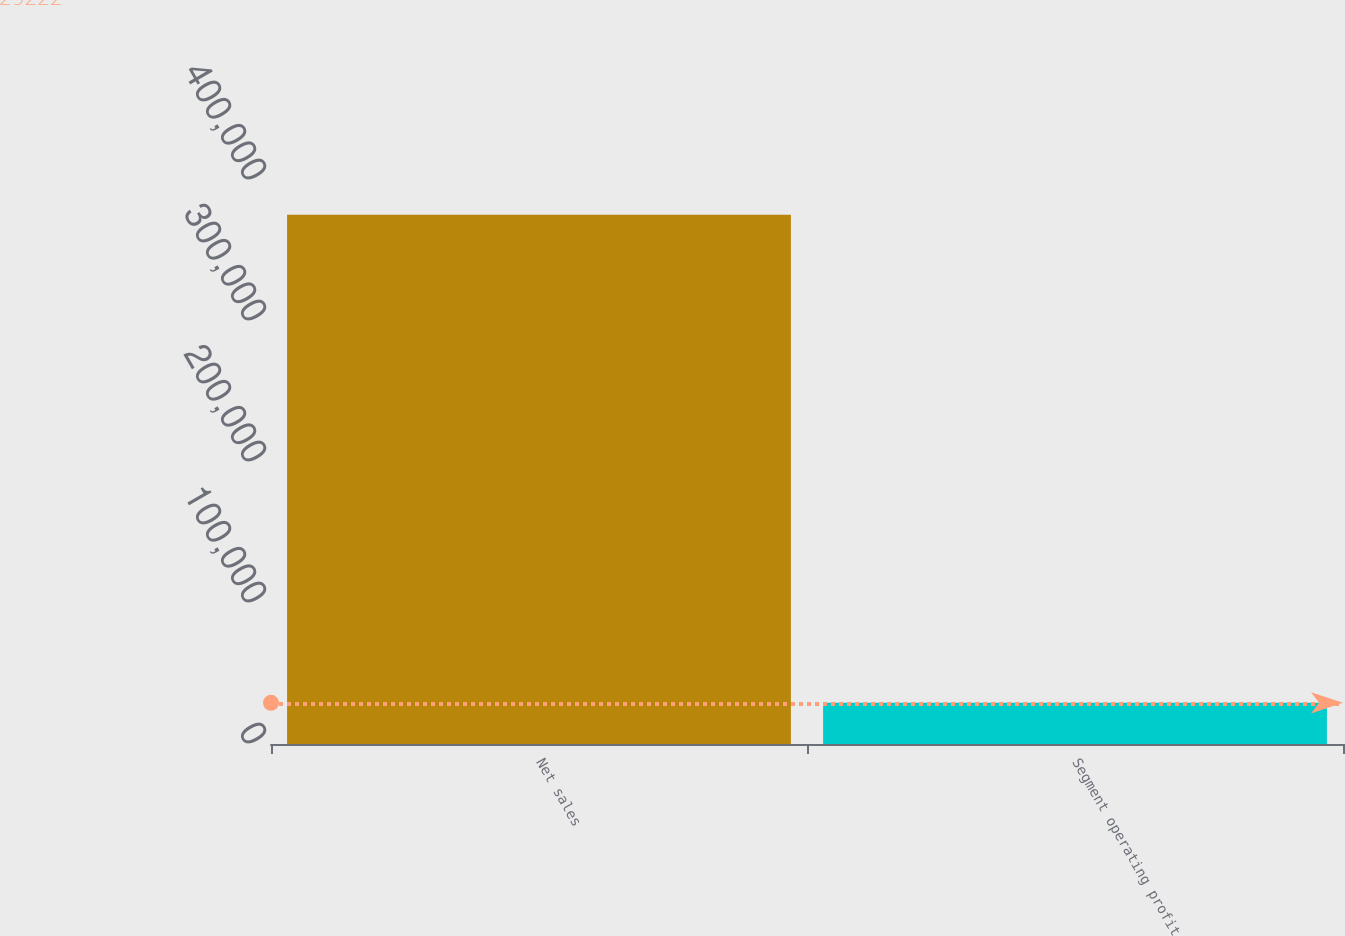Convert chart. <chart><loc_0><loc_0><loc_500><loc_500><bar_chart><fcel>Net sales<fcel>Segment operating profit<nl><fcel>375440<fcel>29222<nl></chart> 